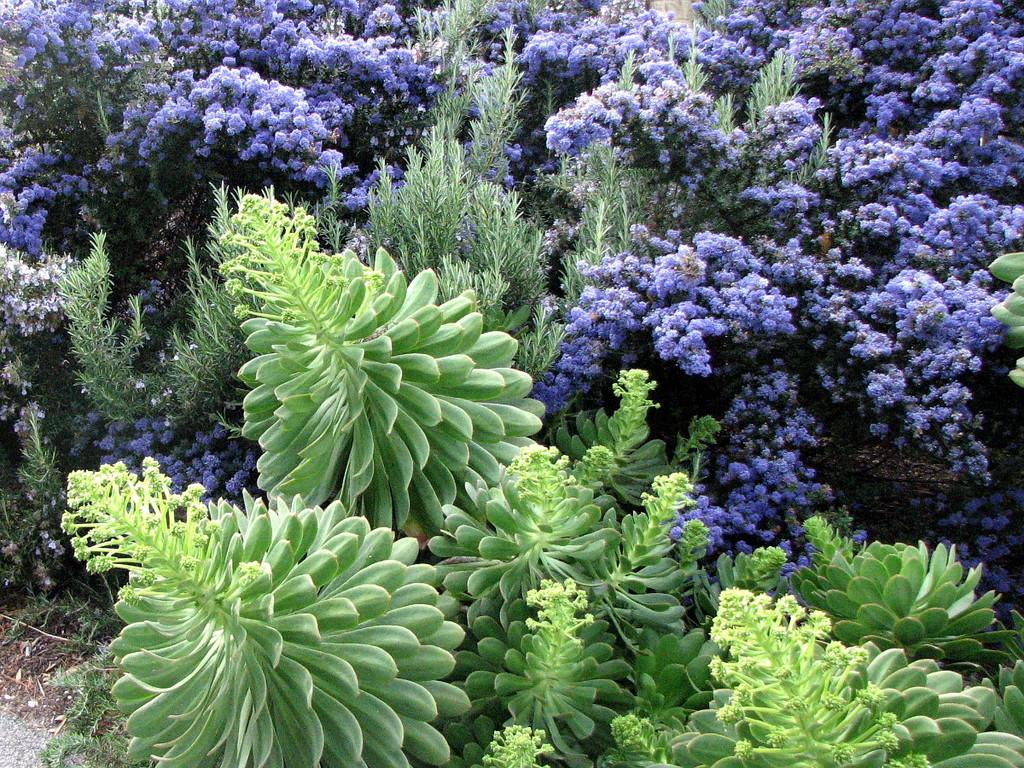What type of vegetation can be seen in the image? There are flowers, plants, and trees in the image. Can you describe the different types of vegetation present? The image contains flowers, which are smaller and more colorful, plants, which are typically green and leafy, and trees, which are larger and have a trunk. How many different types of vegetation are present in the image? There are: There are three different types of vegetation present in the image: flowers, plants, and trees. What type of operation is being performed on the ship in the image? There is no ship present in the image, so it is not possible to answer that question. 